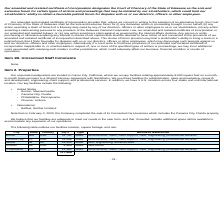According to Nanthealth's financial document, Where is the company's corporate headquarters located? Culver City, California. The document states: "Our corporate headquarters are located in Culver City, California, where we occupy facilities totaling approximately 8,000 square feet on a month-..." Also, What are the respective types of facilities in Boston and Panama City? The document shows two values: Lease and Lease. From the document: "Boston MA USA 31,752 Lease Administrative, sales, client support, R&D, engineering, professional services..." Also, What are the respective square feet of the facilities located in Boston and Phoenix? The document shows two values: 31,752 and 4,865. From the document: "Phoenix AZ USA 4,865 Lease Data center Boston MA USA 31,752 Lease Administrative, sales, client support, R&D, engineering, professional services..." Also, can you calculate: What is the average square feet of the company's facilities in Boston and Panama City? To answer this question, I need to perform calculations using the financial data. The calculation is: (31,752 + 51,288)/2 , which equals 41520. This is based on the information: "Panama City FL USA 51,288 Lease Administrative, sales, client support, R&D, engineering, professional services Boston MA USA 31,752 Lease Administrative, sales, client support, R&D, engineering, profe..." The key data points involved are: 31,752, 51,288. Also, can you calculate: What is the average square feet of the company's facilities in Belfast and Phoenix? To answer this question, I need to perform calculations using the financial data. The calculation is: (15,500 + 4,865)/2 , which equals 10182.5. This is based on the information: "Belfast NI UK 15,500 Lease R&D, engineering, administrative Phoenix AZ USA 4,865 Lease Data center..." The key data points involved are: 15,500, 4,865. Also, can you calculate: What is the value of the company's facility in Phoenix as a percentage of the total square feet of all its facilities in the U.S.? Based on the calculation: 4,865/117,588 , the result is 4.14 (percentage). This is based on the information: "117,588 Phoenix AZ USA 4,865 Lease Data center..." The key data points involved are: 117,588, 4,865. 